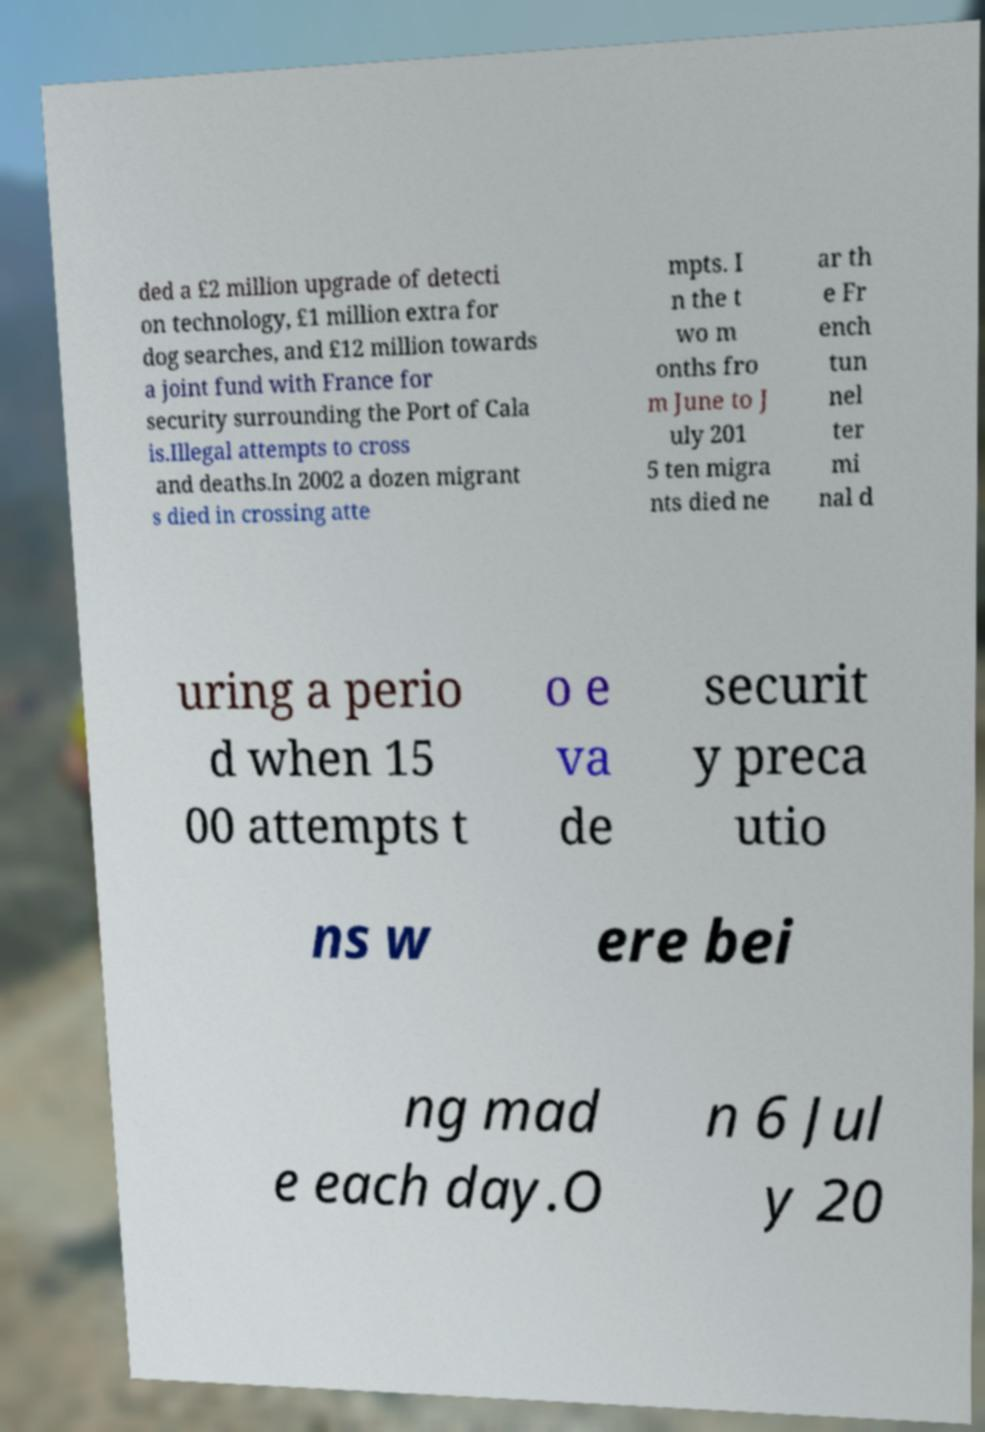Can you read and provide the text displayed in the image?This photo seems to have some interesting text. Can you extract and type it out for me? ded a £2 million upgrade of detecti on technology, £1 million extra for dog searches, and £12 million towards a joint fund with France for security surrounding the Port of Cala is.Illegal attempts to cross and deaths.In 2002 a dozen migrant s died in crossing atte mpts. I n the t wo m onths fro m June to J uly 201 5 ten migra nts died ne ar th e Fr ench tun nel ter mi nal d uring a perio d when 15 00 attempts t o e va de securit y preca utio ns w ere bei ng mad e each day.O n 6 Jul y 20 